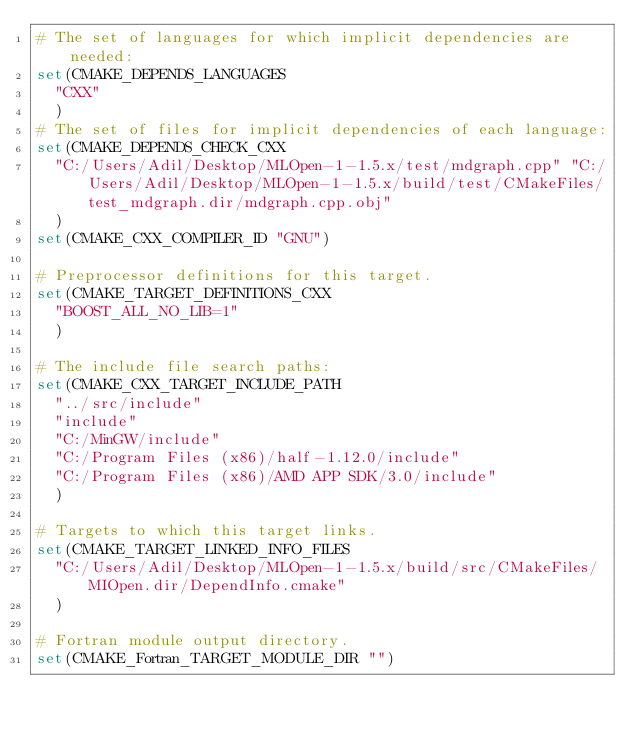<code> <loc_0><loc_0><loc_500><loc_500><_CMake_># The set of languages for which implicit dependencies are needed:
set(CMAKE_DEPENDS_LANGUAGES
  "CXX"
  )
# The set of files for implicit dependencies of each language:
set(CMAKE_DEPENDS_CHECK_CXX
  "C:/Users/Adil/Desktop/MLOpen-1-1.5.x/test/mdgraph.cpp" "C:/Users/Adil/Desktop/MLOpen-1-1.5.x/build/test/CMakeFiles/test_mdgraph.dir/mdgraph.cpp.obj"
  )
set(CMAKE_CXX_COMPILER_ID "GNU")

# Preprocessor definitions for this target.
set(CMAKE_TARGET_DEFINITIONS_CXX
  "BOOST_ALL_NO_LIB=1"
  )

# The include file search paths:
set(CMAKE_CXX_TARGET_INCLUDE_PATH
  "../src/include"
  "include"
  "C:/MinGW/include"
  "C:/Program Files (x86)/half-1.12.0/include"
  "C:/Program Files (x86)/AMD APP SDK/3.0/include"
  )

# Targets to which this target links.
set(CMAKE_TARGET_LINKED_INFO_FILES
  "C:/Users/Adil/Desktop/MLOpen-1-1.5.x/build/src/CMakeFiles/MIOpen.dir/DependInfo.cmake"
  )

# Fortran module output directory.
set(CMAKE_Fortran_TARGET_MODULE_DIR "")
</code> 